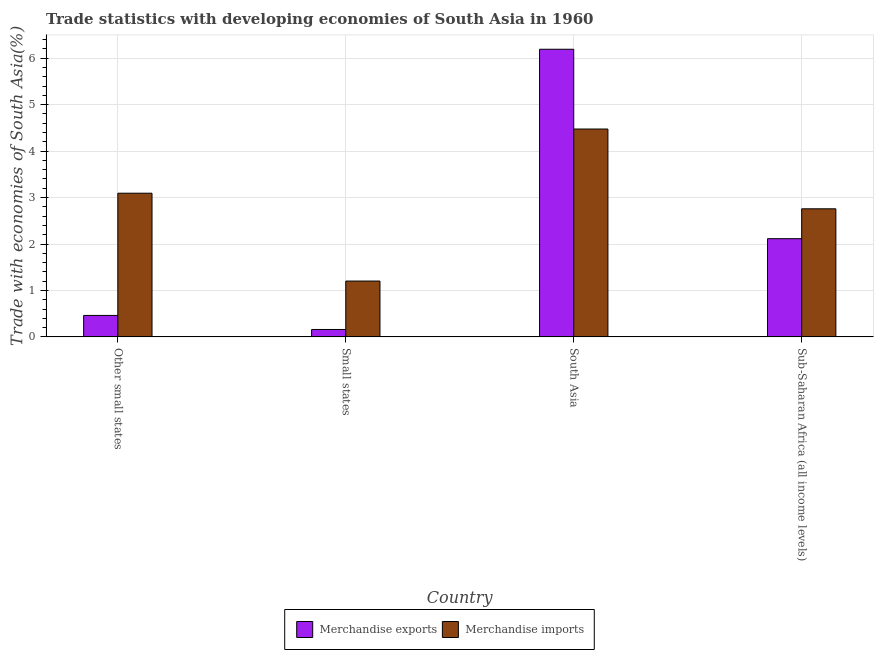How many groups of bars are there?
Your answer should be very brief. 4. How many bars are there on the 4th tick from the left?
Offer a terse response. 2. What is the label of the 3rd group of bars from the left?
Offer a terse response. South Asia. What is the merchandise exports in Other small states?
Your answer should be compact. 0.46. Across all countries, what is the maximum merchandise imports?
Offer a terse response. 4.48. Across all countries, what is the minimum merchandise exports?
Provide a short and direct response. 0.16. In which country was the merchandise exports maximum?
Provide a succinct answer. South Asia. In which country was the merchandise exports minimum?
Your answer should be very brief. Small states. What is the total merchandise exports in the graph?
Your answer should be compact. 8.93. What is the difference between the merchandise exports in Other small states and that in Small states?
Make the answer very short. 0.3. What is the difference between the merchandise exports in Small states and the merchandise imports in Other small states?
Ensure brevity in your answer.  -2.93. What is the average merchandise imports per country?
Ensure brevity in your answer.  2.88. What is the difference between the merchandise imports and merchandise exports in Other small states?
Your answer should be compact. 2.63. In how many countries, is the merchandise imports greater than 3.4 %?
Provide a short and direct response. 1. What is the ratio of the merchandise imports in South Asia to that in Sub-Saharan Africa (all income levels)?
Give a very brief answer. 1.62. Is the merchandise imports in Other small states less than that in South Asia?
Ensure brevity in your answer.  Yes. Is the difference between the merchandise imports in Small states and South Asia greater than the difference between the merchandise exports in Small states and South Asia?
Provide a succinct answer. Yes. What is the difference between the highest and the second highest merchandise imports?
Give a very brief answer. 1.38. What is the difference between the highest and the lowest merchandise exports?
Keep it short and to the point. 6.03. In how many countries, is the merchandise imports greater than the average merchandise imports taken over all countries?
Keep it short and to the point. 2. Is the sum of the merchandise imports in Other small states and Small states greater than the maximum merchandise exports across all countries?
Your answer should be very brief. No. What does the 1st bar from the right in Sub-Saharan Africa (all income levels) represents?
Offer a terse response. Merchandise imports. What is the difference between two consecutive major ticks on the Y-axis?
Ensure brevity in your answer.  1. Does the graph contain any zero values?
Give a very brief answer. No. How many legend labels are there?
Provide a succinct answer. 2. What is the title of the graph?
Keep it short and to the point. Trade statistics with developing economies of South Asia in 1960. Does "Electricity" appear as one of the legend labels in the graph?
Your response must be concise. No. What is the label or title of the Y-axis?
Offer a very short reply. Trade with economies of South Asia(%). What is the Trade with economies of South Asia(%) of Merchandise exports in Other small states?
Keep it short and to the point. 0.46. What is the Trade with economies of South Asia(%) in Merchandise imports in Other small states?
Your response must be concise. 3.09. What is the Trade with economies of South Asia(%) of Merchandise exports in Small states?
Your answer should be very brief. 0.16. What is the Trade with economies of South Asia(%) of Merchandise imports in Small states?
Provide a succinct answer. 1.2. What is the Trade with economies of South Asia(%) of Merchandise exports in South Asia?
Your response must be concise. 6.19. What is the Trade with economies of South Asia(%) of Merchandise imports in South Asia?
Ensure brevity in your answer.  4.48. What is the Trade with economies of South Asia(%) in Merchandise exports in Sub-Saharan Africa (all income levels)?
Keep it short and to the point. 2.11. What is the Trade with economies of South Asia(%) in Merchandise imports in Sub-Saharan Africa (all income levels)?
Give a very brief answer. 2.76. Across all countries, what is the maximum Trade with economies of South Asia(%) in Merchandise exports?
Your answer should be compact. 6.19. Across all countries, what is the maximum Trade with economies of South Asia(%) of Merchandise imports?
Your answer should be compact. 4.48. Across all countries, what is the minimum Trade with economies of South Asia(%) in Merchandise exports?
Keep it short and to the point. 0.16. Across all countries, what is the minimum Trade with economies of South Asia(%) in Merchandise imports?
Give a very brief answer. 1.2. What is the total Trade with economies of South Asia(%) of Merchandise exports in the graph?
Give a very brief answer. 8.93. What is the total Trade with economies of South Asia(%) in Merchandise imports in the graph?
Keep it short and to the point. 11.53. What is the difference between the Trade with economies of South Asia(%) of Merchandise exports in Other small states and that in Small states?
Provide a succinct answer. 0.3. What is the difference between the Trade with economies of South Asia(%) in Merchandise imports in Other small states and that in Small states?
Provide a succinct answer. 1.89. What is the difference between the Trade with economies of South Asia(%) of Merchandise exports in Other small states and that in South Asia?
Provide a short and direct response. -5.73. What is the difference between the Trade with economies of South Asia(%) in Merchandise imports in Other small states and that in South Asia?
Your response must be concise. -1.38. What is the difference between the Trade with economies of South Asia(%) in Merchandise exports in Other small states and that in Sub-Saharan Africa (all income levels)?
Make the answer very short. -1.65. What is the difference between the Trade with economies of South Asia(%) in Merchandise imports in Other small states and that in Sub-Saharan Africa (all income levels)?
Your response must be concise. 0.34. What is the difference between the Trade with economies of South Asia(%) of Merchandise exports in Small states and that in South Asia?
Provide a short and direct response. -6.03. What is the difference between the Trade with economies of South Asia(%) of Merchandise imports in Small states and that in South Asia?
Offer a very short reply. -3.27. What is the difference between the Trade with economies of South Asia(%) of Merchandise exports in Small states and that in Sub-Saharan Africa (all income levels)?
Ensure brevity in your answer.  -1.96. What is the difference between the Trade with economies of South Asia(%) of Merchandise imports in Small states and that in Sub-Saharan Africa (all income levels)?
Ensure brevity in your answer.  -1.56. What is the difference between the Trade with economies of South Asia(%) in Merchandise exports in South Asia and that in Sub-Saharan Africa (all income levels)?
Make the answer very short. 4.08. What is the difference between the Trade with economies of South Asia(%) of Merchandise imports in South Asia and that in Sub-Saharan Africa (all income levels)?
Ensure brevity in your answer.  1.72. What is the difference between the Trade with economies of South Asia(%) in Merchandise exports in Other small states and the Trade with economies of South Asia(%) in Merchandise imports in Small states?
Offer a terse response. -0.74. What is the difference between the Trade with economies of South Asia(%) in Merchandise exports in Other small states and the Trade with economies of South Asia(%) in Merchandise imports in South Asia?
Keep it short and to the point. -4.01. What is the difference between the Trade with economies of South Asia(%) of Merchandise exports in Other small states and the Trade with economies of South Asia(%) of Merchandise imports in Sub-Saharan Africa (all income levels)?
Give a very brief answer. -2.3. What is the difference between the Trade with economies of South Asia(%) of Merchandise exports in Small states and the Trade with economies of South Asia(%) of Merchandise imports in South Asia?
Offer a very short reply. -4.32. What is the difference between the Trade with economies of South Asia(%) of Merchandise exports in Small states and the Trade with economies of South Asia(%) of Merchandise imports in Sub-Saharan Africa (all income levels)?
Offer a very short reply. -2.6. What is the difference between the Trade with economies of South Asia(%) in Merchandise exports in South Asia and the Trade with economies of South Asia(%) in Merchandise imports in Sub-Saharan Africa (all income levels)?
Provide a short and direct response. 3.44. What is the average Trade with economies of South Asia(%) in Merchandise exports per country?
Ensure brevity in your answer.  2.23. What is the average Trade with economies of South Asia(%) in Merchandise imports per country?
Offer a very short reply. 2.88. What is the difference between the Trade with economies of South Asia(%) in Merchandise exports and Trade with economies of South Asia(%) in Merchandise imports in Other small states?
Your answer should be very brief. -2.63. What is the difference between the Trade with economies of South Asia(%) in Merchandise exports and Trade with economies of South Asia(%) in Merchandise imports in Small states?
Provide a succinct answer. -1.04. What is the difference between the Trade with economies of South Asia(%) in Merchandise exports and Trade with economies of South Asia(%) in Merchandise imports in South Asia?
Your answer should be very brief. 1.72. What is the difference between the Trade with economies of South Asia(%) in Merchandise exports and Trade with economies of South Asia(%) in Merchandise imports in Sub-Saharan Africa (all income levels)?
Make the answer very short. -0.64. What is the ratio of the Trade with economies of South Asia(%) in Merchandise exports in Other small states to that in Small states?
Your response must be concise. 2.9. What is the ratio of the Trade with economies of South Asia(%) in Merchandise imports in Other small states to that in Small states?
Your response must be concise. 2.57. What is the ratio of the Trade with economies of South Asia(%) in Merchandise exports in Other small states to that in South Asia?
Your response must be concise. 0.07. What is the ratio of the Trade with economies of South Asia(%) of Merchandise imports in Other small states to that in South Asia?
Ensure brevity in your answer.  0.69. What is the ratio of the Trade with economies of South Asia(%) in Merchandise exports in Other small states to that in Sub-Saharan Africa (all income levels)?
Make the answer very short. 0.22. What is the ratio of the Trade with economies of South Asia(%) in Merchandise imports in Other small states to that in Sub-Saharan Africa (all income levels)?
Provide a short and direct response. 1.12. What is the ratio of the Trade with economies of South Asia(%) in Merchandise exports in Small states to that in South Asia?
Make the answer very short. 0.03. What is the ratio of the Trade with economies of South Asia(%) in Merchandise imports in Small states to that in South Asia?
Provide a short and direct response. 0.27. What is the ratio of the Trade with economies of South Asia(%) of Merchandise exports in Small states to that in Sub-Saharan Africa (all income levels)?
Keep it short and to the point. 0.08. What is the ratio of the Trade with economies of South Asia(%) in Merchandise imports in Small states to that in Sub-Saharan Africa (all income levels)?
Give a very brief answer. 0.44. What is the ratio of the Trade with economies of South Asia(%) of Merchandise exports in South Asia to that in Sub-Saharan Africa (all income levels)?
Keep it short and to the point. 2.93. What is the ratio of the Trade with economies of South Asia(%) in Merchandise imports in South Asia to that in Sub-Saharan Africa (all income levels)?
Make the answer very short. 1.62. What is the difference between the highest and the second highest Trade with economies of South Asia(%) of Merchandise exports?
Give a very brief answer. 4.08. What is the difference between the highest and the second highest Trade with economies of South Asia(%) of Merchandise imports?
Keep it short and to the point. 1.38. What is the difference between the highest and the lowest Trade with economies of South Asia(%) in Merchandise exports?
Your answer should be very brief. 6.03. What is the difference between the highest and the lowest Trade with economies of South Asia(%) of Merchandise imports?
Offer a terse response. 3.27. 